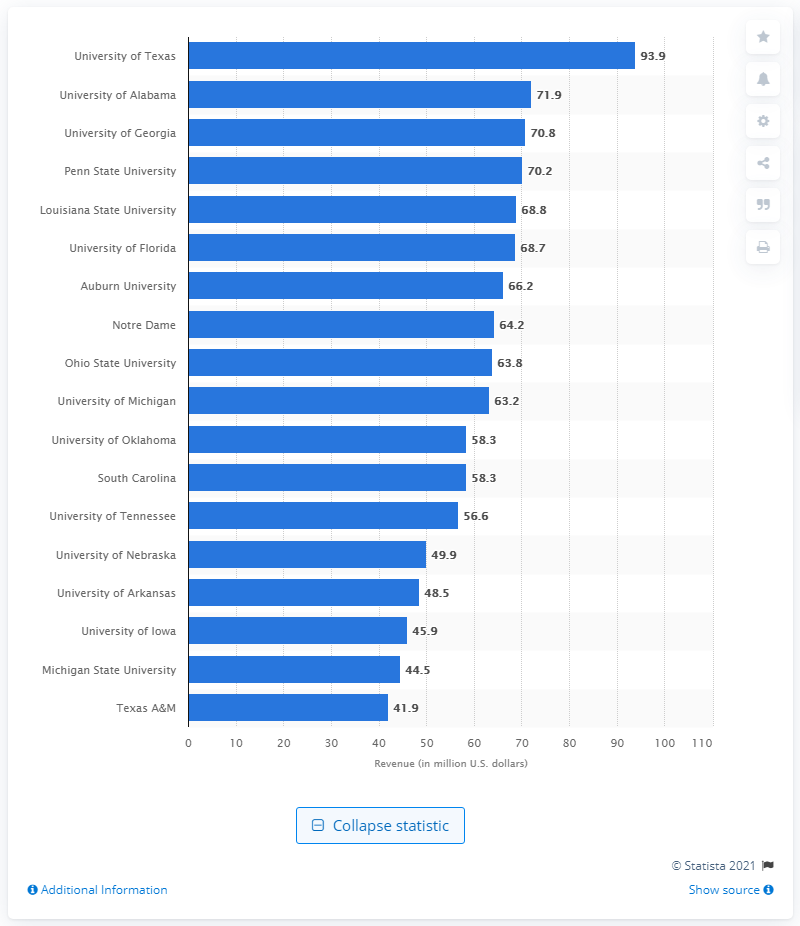Draw attention to some important aspects in this diagram. In 2011, the University of Michigan generated a revenue of 63.2 million dollars. 